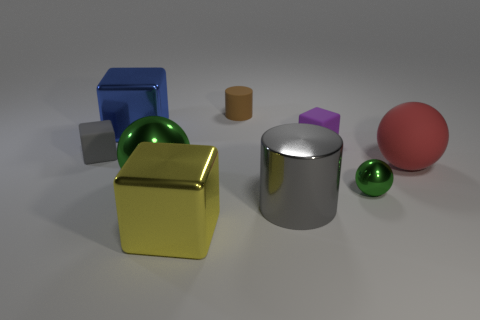What elements in this image could relate to concepts in geometry? This image is rich with geometric shapes that offer a practical demonstration of geometry concepts. For instance, we see spheres, cubes, and a cylinder. Each of these forms can be used to discuss volume, surface area, and the properties of three-dimensional shapes, such as edges, vertices, and faces.  Which of these objects seems out of place compared to the others? Considering the image, all objects are congruent with the theme of geometrical shapes; however, the small brown cylinder stands out due to its smaller size and lack of glossiness when compared to the other, more reflective objects. 